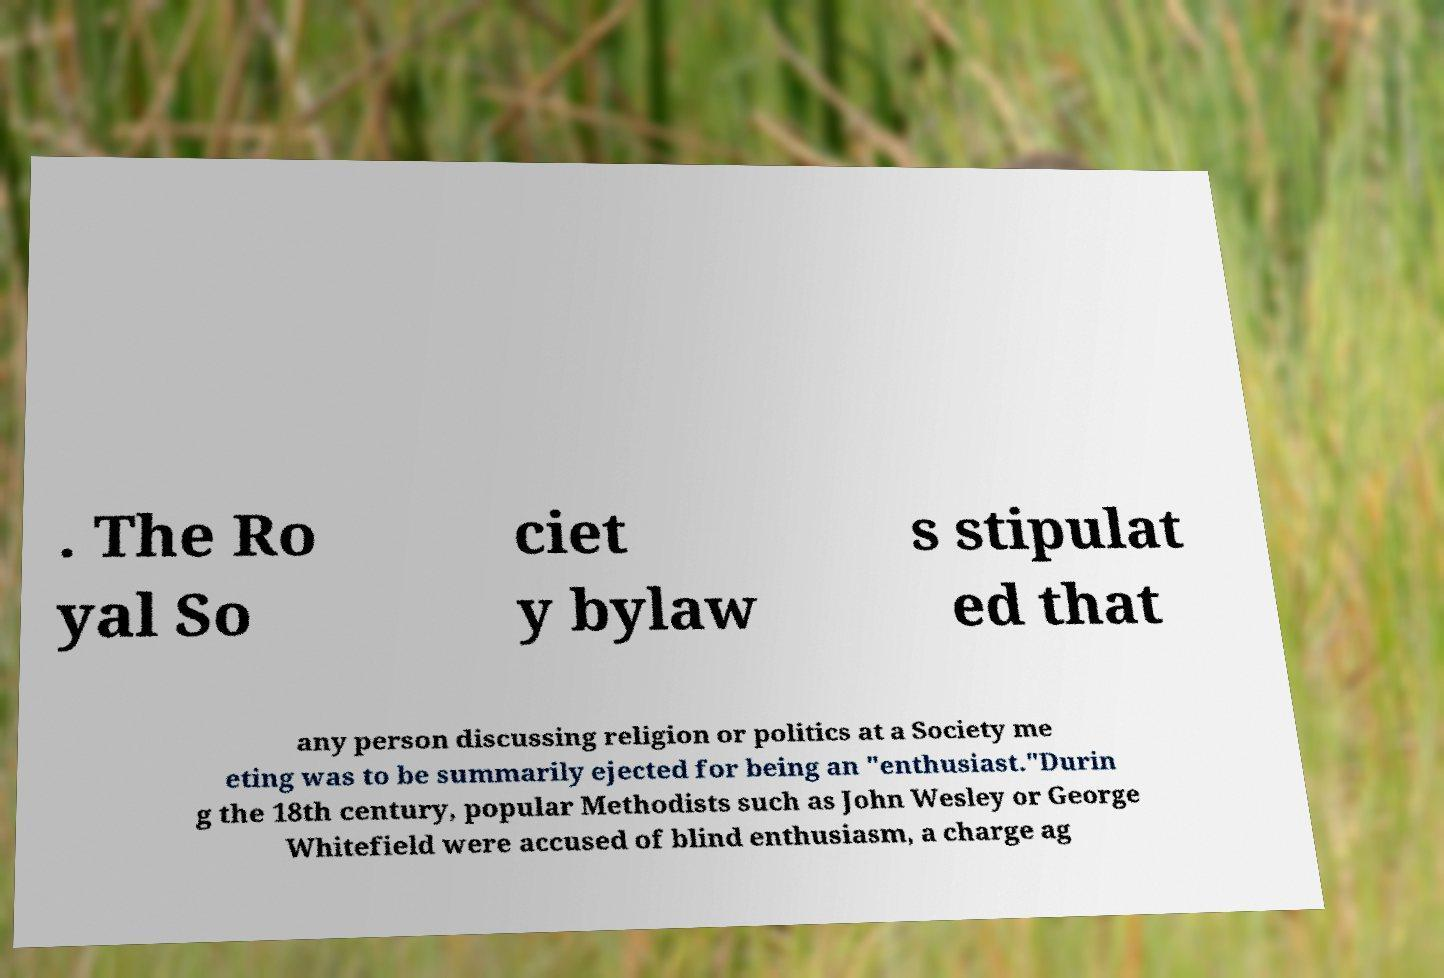Please read and relay the text visible in this image. What does it say? . The Ro yal So ciet y bylaw s stipulat ed that any person discussing religion or politics at a Society me eting was to be summarily ejected for being an "enthusiast."Durin g the 18th century, popular Methodists such as John Wesley or George Whitefield were accused of blind enthusiasm, a charge ag 